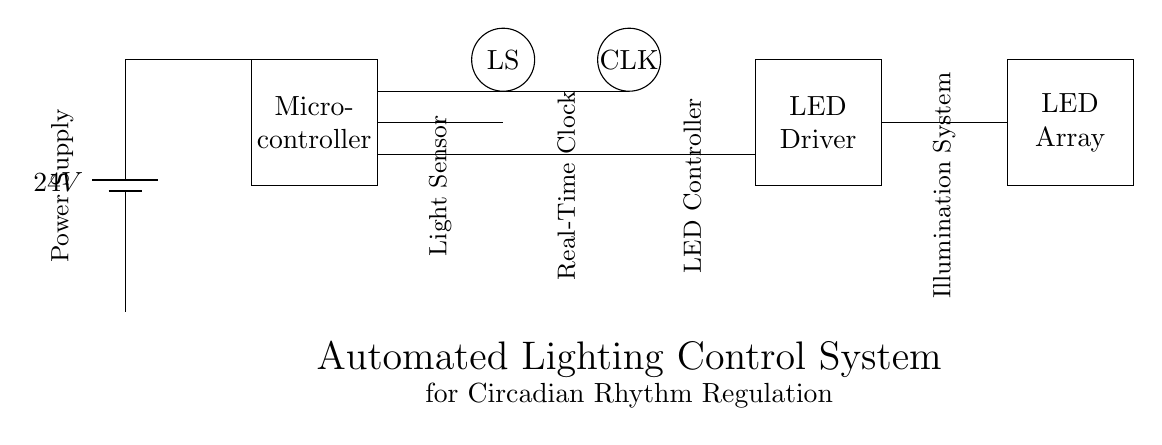What is the power supply voltage? The power supply voltage is indicated as 24 volts, which is shown on the battery symbol in the diagram.
Answer: 24 volts What is the function of the Light Sensor? The Light Sensor detects ambient light levels and sends this information to the microcontroller to adjust the lighting accordingly. This functionality is integral for regulating circadian rhythms.
Answer: Detect ambient light levels What connects the microcontroller to the LED driver? The connection from the microcontroller to the LED driver is a directed line indicating that the microcontroller controls the LED driver based on inputs from the light sensor.
Answer: A direct line What is the role of the Clock component? The Clock component provides real-time data to the microcontroller, allowing it to operate in sync with the biological timing information necessary for circadian rhythm management.
Answer: Provide real-time data How does the system respond to changes in light detected by the sensor? When the light sensor detects changes in ambient light, it sends a signal to the microcontroller, which then adjusts the LED array's brightness through the LED driver accordingly, maintaining an optimal light environment for sleep studies.
Answer: Adjust the LED array brightness What type of components are used to regulate lighting in this circuit? The components such as the microcontroller, light sensor, LED driver, and LED array work together in an automated system to regulate lighting effectively.
Answer: Automated components Which component receives inputs from the light sensor? The microcontroller receives inputs from the light sensor, processing the data to control the LED driver based on the detected lighting conditions in the environment.
Answer: Microcontroller 